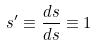<formula> <loc_0><loc_0><loc_500><loc_500>s ^ { \prime } \equiv \frac { d s } { d s } \equiv 1</formula> 